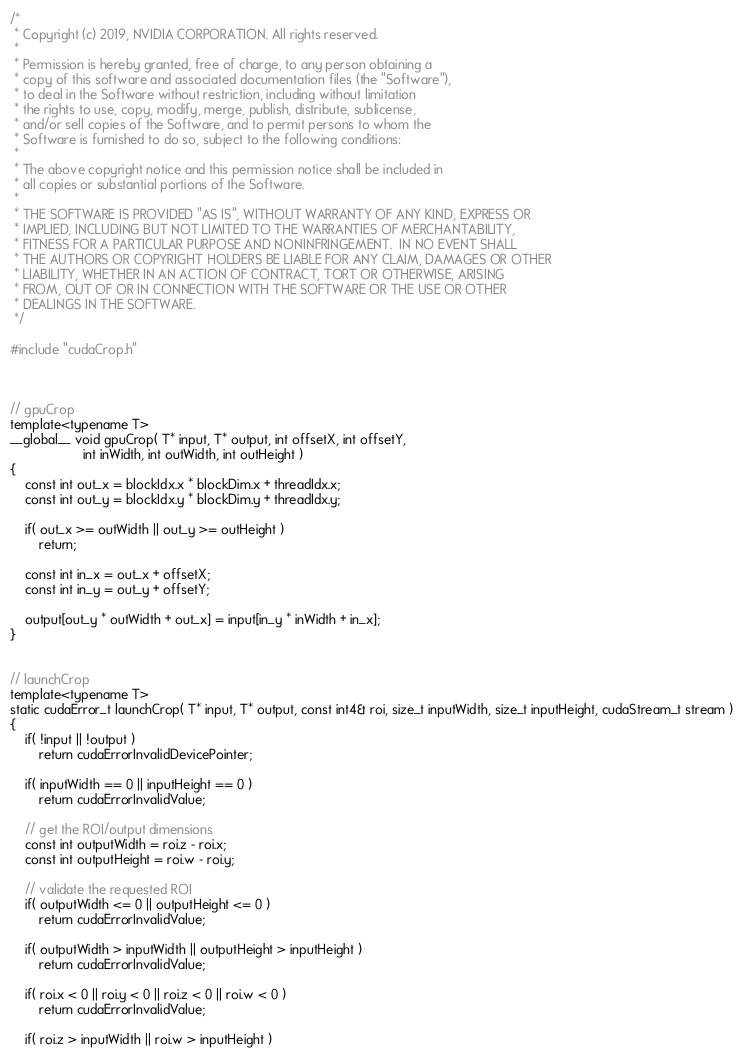Convert code to text. <code><loc_0><loc_0><loc_500><loc_500><_Cuda_>/*
 * Copyright (c) 2019, NVIDIA CORPORATION. All rights reserved.
 *
 * Permission is hereby granted, free of charge, to any person obtaining a
 * copy of this software and associated documentation files (the "Software"),
 * to deal in the Software without restriction, including without limitation
 * the rights to use, copy, modify, merge, publish, distribute, sublicense,
 * and/or sell copies of the Software, and to permit persons to whom the
 * Software is furnished to do so, subject to the following conditions:
 *
 * The above copyright notice and this permission notice shall be included in
 * all copies or substantial portions of the Software.
 *
 * THE SOFTWARE IS PROVIDED "AS IS", WITHOUT WARRANTY OF ANY KIND, EXPRESS OR
 * IMPLIED, INCLUDING BUT NOT LIMITED TO THE WARRANTIES OF MERCHANTABILITY,
 * FITNESS FOR A PARTICULAR PURPOSE AND NONINFRINGEMENT.  IN NO EVENT SHALL
 * THE AUTHORS OR COPYRIGHT HOLDERS BE LIABLE FOR ANY CLAIM, DAMAGES OR OTHER
 * LIABILITY, WHETHER IN AN ACTION OF CONTRACT, TORT OR OTHERWISE, ARISING
 * FROM, OUT OF OR IN CONNECTION WITH THE SOFTWARE OR THE USE OR OTHER
 * DEALINGS IN THE SOFTWARE.
 */

#include "cudaCrop.h"



// gpuCrop
template<typename T>
__global__ void gpuCrop( T* input, T* output, int offsetX, int offsetY, 
					int inWidth, int outWidth, int outHeight )
{
	const int out_x = blockIdx.x * blockDim.x + threadIdx.x;
	const int out_y = blockIdx.y * blockDim.y + threadIdx.y;

	if( out_x >= outWidth || out_y >= outHeight )
		return;

	const int in_x = out_x + offsetX;
	const int in_y = out_y + offsetY;

	output[out_y * outWidth + out_x] = input[in_y * inWidth + in_x];
}


// launchCrop
template<typename T>
static cudaError_t launchCrop( T* input, T* output, const int4& roi, size_t inputWidth, size_t inputHeight, cudaStream_t stream )
{
	if( !input || !output )
		return cudaErrorInvalidDevicePointer;

	if( inputWidth == 0 || inputHeight == 0 )
		return cudaErrorInvalidValue;

	// get the ROI/output dimensions
	const int outputWidth = roi.z - roi.x;
	const int outputHeight = roi.w - roi.y;

	// validate the requested ROI
	if( outputWidth <= 0 || outputHeight <= 0 )
		return cudaErrorInvalidValue;

	if( outputWidth > inputWidth || outputHeight > inputHeight )
		return cudaErrorInvalidValue;

	if( roi.x < 0 || roi.y < 0 || roi.z < 0 || roi.w < 0 )
		return cudaErrorInvalidValue;

	if( roi.z > inputWidth || roi.w > inputHeight )</code> 